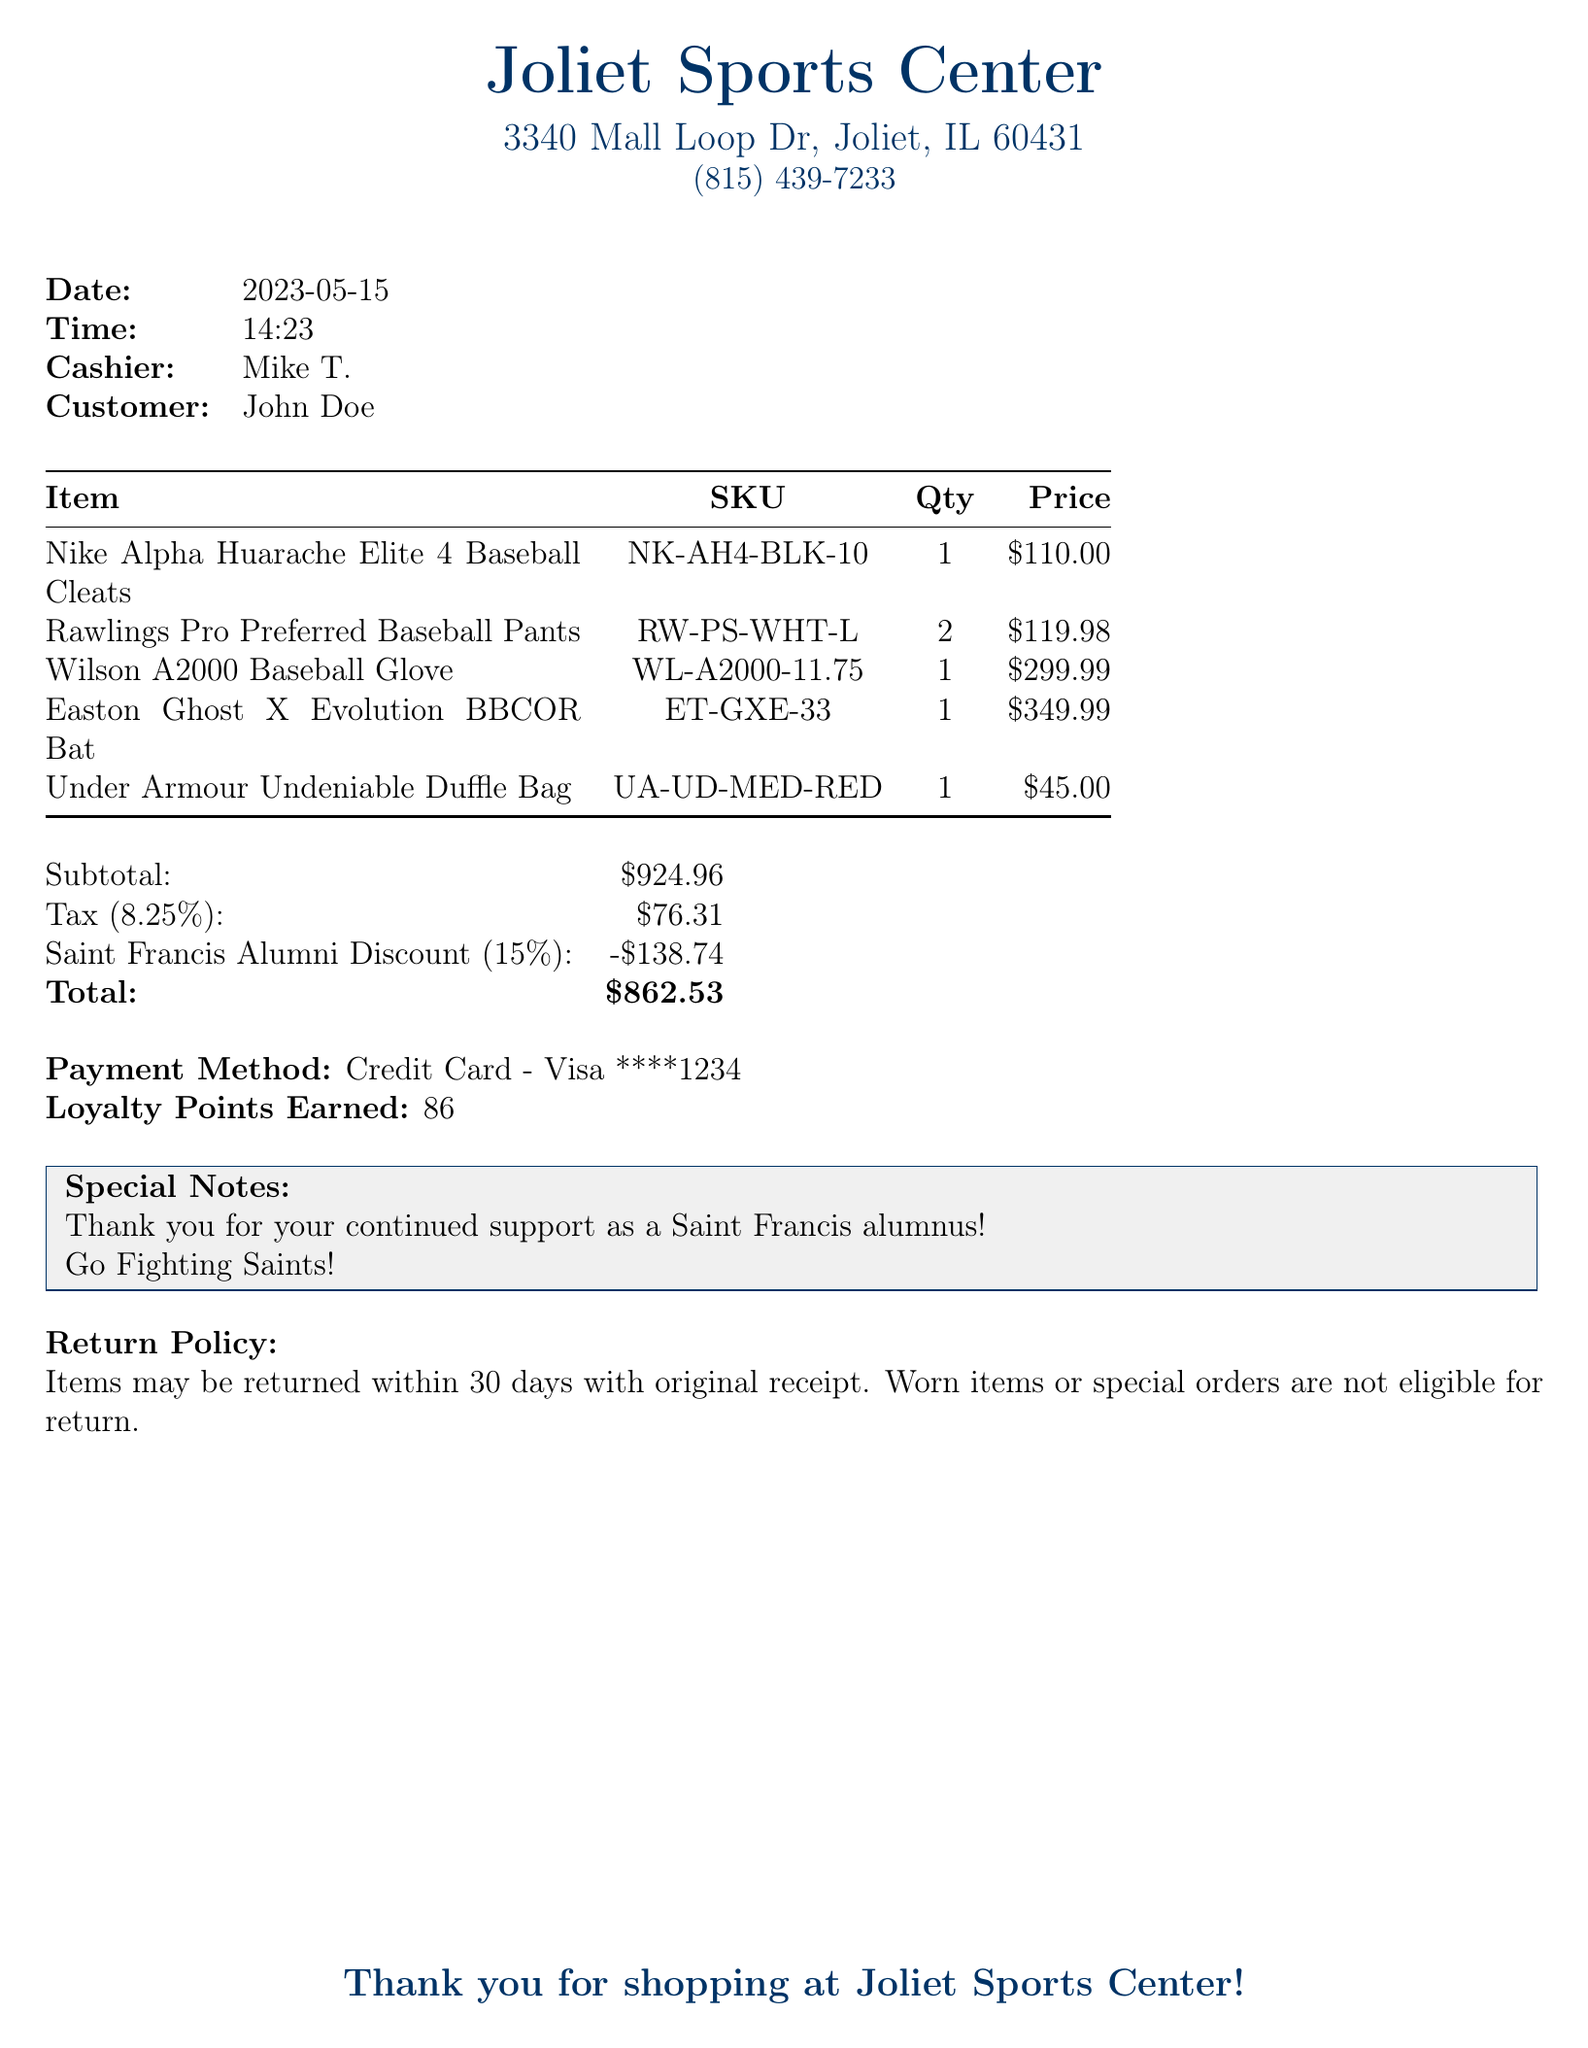what is the store name? The store name is listed at the top of the receipt, which is Joliet Sports Center.
Answer: Joliet Sports Center what is the address of the store? The address is provided under the store name, which indicates the location of the store.
Answer: 3340 Mall Loop Dr, Joliet, IL 60431 who was the cashier? The cashier's name is mentioned in the customer service section of the receipt.
Answer: Mike T what is the subtotal amount? The subtotal before tax and discounts is specified in the financial summary of the receipt.
Answer: $924.96 what was the amount of the discount? The discount amount is detailed under the discounts section, indicating the savings applied to the total.
Answer: -$138.74 how many loyalty points were earned? The earned loyalty points are listed at the end of the document as part of the purchase benefits.
Answer: 86 what is the tax rate? The tax rate is expressed as a percentage in the financial summary of the receipt.
Answer: 8.25% when was the purchase made? The date of the transaction is clearly indicated on the receipt.
Answer: 2023-05-15 what is the payment method? The payment method used for this transaction is specified at the end of the receipt.
Answer: Credit Card - Visa ****1234 